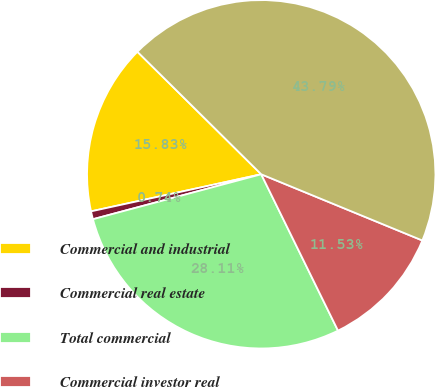Convert chart. <chart><loc_0><loc_0><loc_500><loc_500><pie_chart><fcel>Commercial and industrial<fcel>Commercial real estate<fcel>Total commercial<fcel>Commercial investor real<fcel>Total investor real estate<nl><fcel>15.83%<fcel>0.74%<fcel>28.11%<fcel>11.53%<fcel>43.79%<nl></chart> 